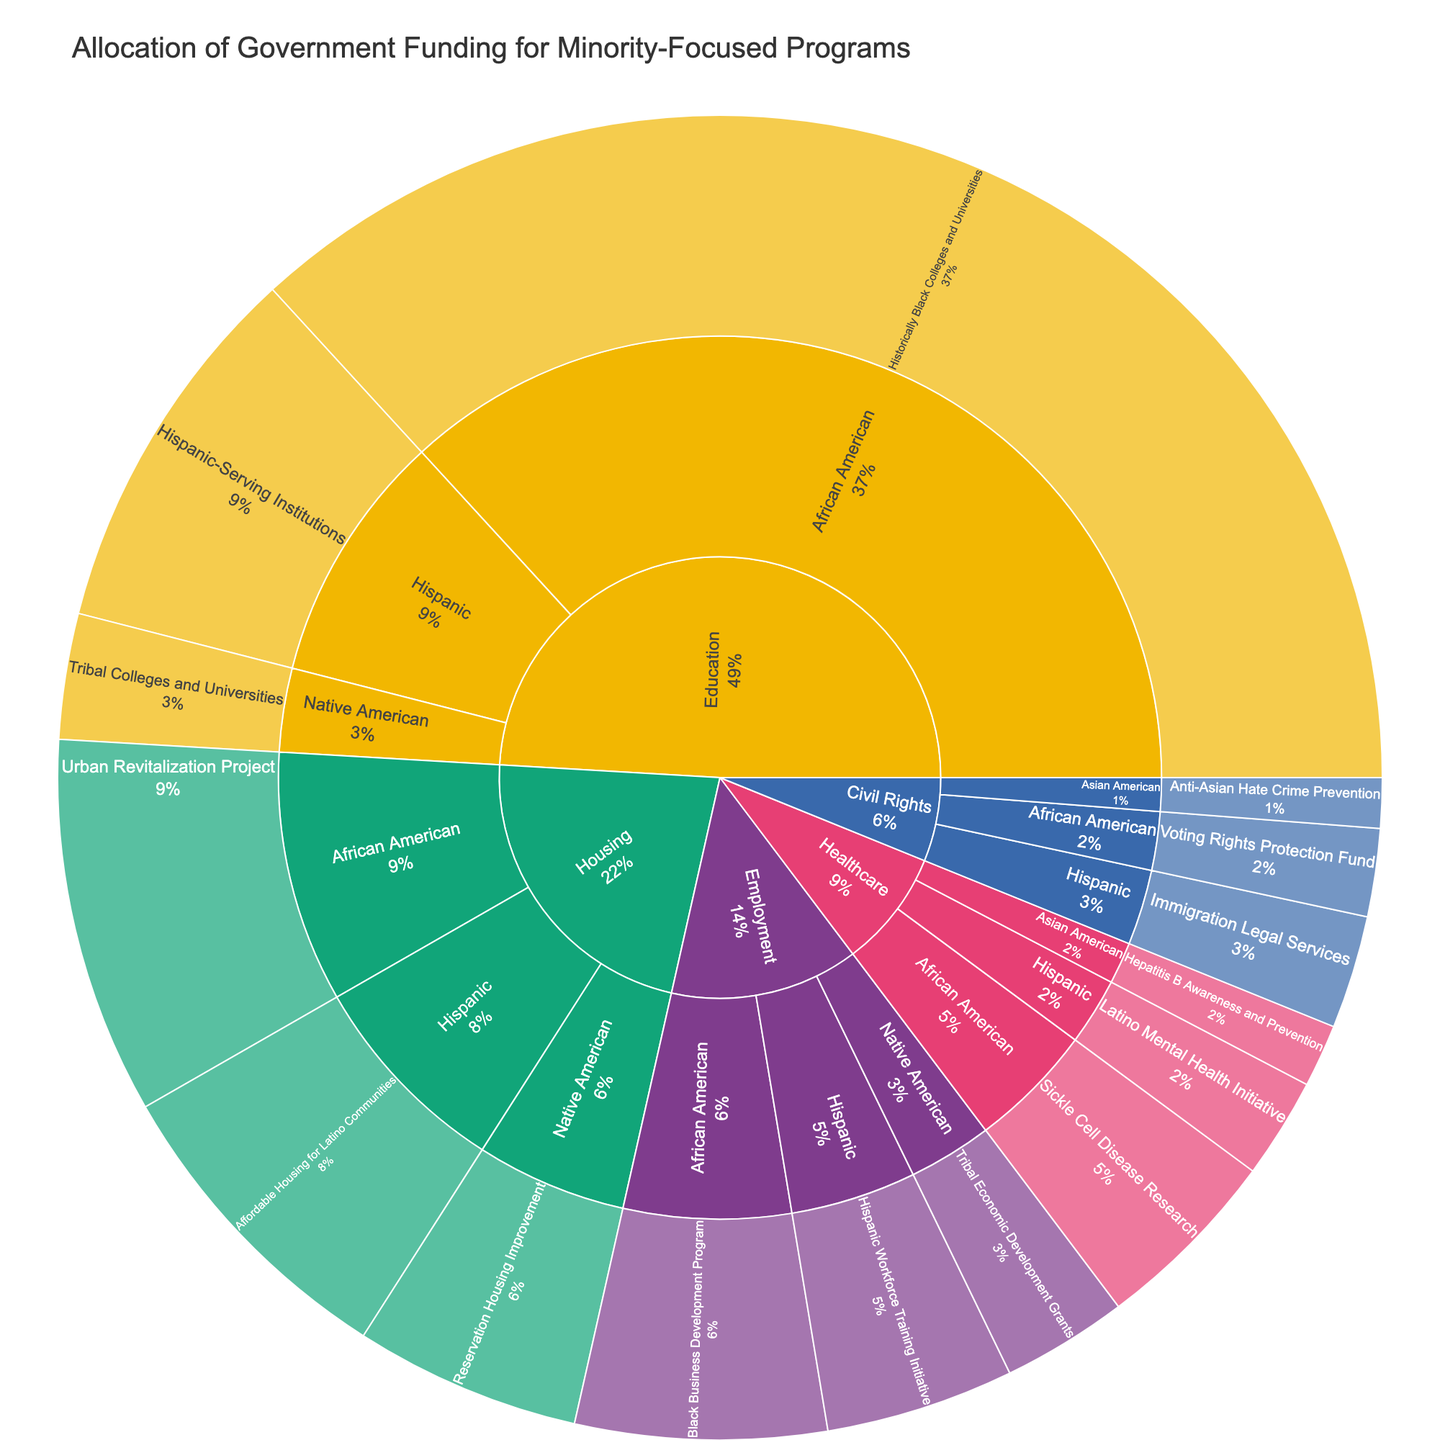How much funding is allocated to the "Healthcare" sector? Sum all the funding amounts under the "Healthcare" sector: $150,000,000 for African American programs, $80,000,000 for Hispanic programs, and $50,000,000 for Asian American programs. The total is $150,000,000 + $80,000,000 + $50,000,000 = $280,000,000.
Answer: $280,000,000 Which demographic group receives the most funding in the "Housing" sector? Compare the funding amounts for each demographic group within the "Housing" sector: African American ($300,000,000), Hispanic ($250,000,000), and Native American ($180,000,000). The African American group receives the most funding.
Answer: African American What percentage of the total funding is allocated to "Education" sector programs for the Hispanic demographic group? First, calculate the total funding amount for all programs. Sum all the funding values: $3,670,000,000. Then, find the funding for the Hispanic demographic in the Education sector ($300,000,000). Percentage = ($300,000,000 / $3,670,000,000) * 100 = 8.17%.
Answer: 8.17% Which single program receives the highest funding, and how much does it receive? Examine the funding amounts for each program. The "Historically Black Colleges and Universities" program in Education receives the highest funding amount of $1,200,000,000.
Answer: Historically Black Colleges and Universities, $1,200,000,000 Compare the total funding for "African American" programs vs. "Hispanic" programs. Which group receives more funding and by how much? Calculate the total funding for "African American" programs: $1,200,000,000 (Education) + $150,000,000 (Healthcare) + $200,000,000 (Employment) + $300,000,000 (Housing) + $70,000,000 (Civil Rights) = $1,920,000,000. Calculate the total funding for "Hispanic" programs: $300,000,000 (Education) + $80,000,000 (Healthcare) + $150,000,000 (Employment) + $250,000,000 (Housing) + $90,000,000 (Civil Rights) = $870,000,000. Compare the totals: $1,920,000,000 - $870,000,000 = $1,050,000,000 more for African American programs.
Answer: African American, $1,050,000,000 What proportion of total government funding is allocated to "Employment" sector programs? Sum the funding for the "Employment" sector: $200,000,000 (African American) + $150,000,000 (Hispanic) + $100,000,000 (Native American) = $450,000,000. Compute the proportion: ($450,000,000 / $3,670,000,000) = 0.1226, approximately 12.26%.
Answer: 12.26% What is the total funding provided to "Civil Rights" initiatives across all demographic groups? Sum the funding amounts across all demographic groups in the "Civil Rights" sector: $70,000,000 (African American) + $90,000,000 (Hispanic) + $40,000,000 (Asian American) = $200,000,000.
Answer: $200,000,000 Which "Education" sector program receives the least funding? Compare the funding amounts for each program under the "Education" sector: "Historically Black Colleges and Universities" ($1,200,000,000), "Hispanic-Serving Institutions" ($300,000,000), and "Tribal Colleges and Universities" ($100,000,000). The "Tribal Colleges and Universities" program receives the least funding.
Answer: Tribal Colleges and Universities What is the average funding per sector? Sum the funding for all sectors: $3,670,000,000. Divide by the number of sectors (5): $3,670,000,000 / 5 = $734,000,000.
Answer: $734,000,000 How does the funding for "Anti-Asian Hate Crime Prevention" compare to "Immigration Legal Services"? Compare the funding amounts: "Anti-Asian Hate Crime Prevention" receives $40,000,000, while "Immigration Legal Services" receives $90,000,000.
Answer: Immigration Legal Services receives $50,000,000 more 